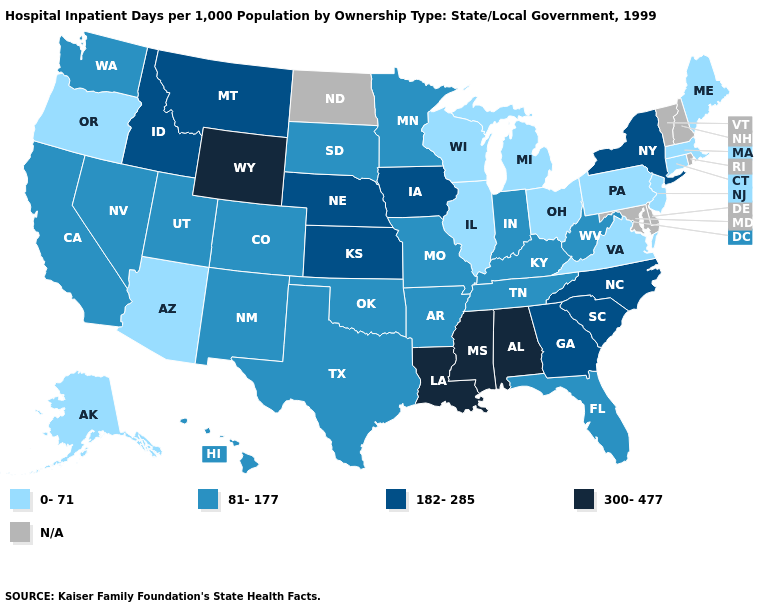Among the states that border Colorado , which have the highest value?
Concise answer only. Wyoming. What is the highest value in the Northeast ?
Give a very brief answer. 182-285. What is the highest value in states that border Texas?
Answer briefly. 300-477. Name the states that have a value in the range N/A?
Give a very brief answer. Delaware, Maryland, New Hampshire, North Dakota, Rhode Island, Vermont. Name the states that have a value in the range 0-71?
Write a very short answer. Alaska, Arizona, Connecticut, Illinois, Maine, Massachusetts, Michigan, New Jersey, Ohio, Oregon, Pennsylvania, Virginia, Wisconsin. What is the value of Louisiana?
Short answer required. 300-477. Does Alabama have the highest value in the USA?
Write a very short answer. Yes. Does Wisconsin have the lowest value in the USA?
Quick response, please. Yes. What is the value of Oregon?
Keep it brief. 0-71. What is the value of Colorado?
Be succinct. 81-177. Name the states that have a value in the range 300-477?
Concise answer only. Alabama, Louisiana, Mississippi, Wyoming. Does Kansas have the lowest value in the MidWest?
Quick response, please. No. 